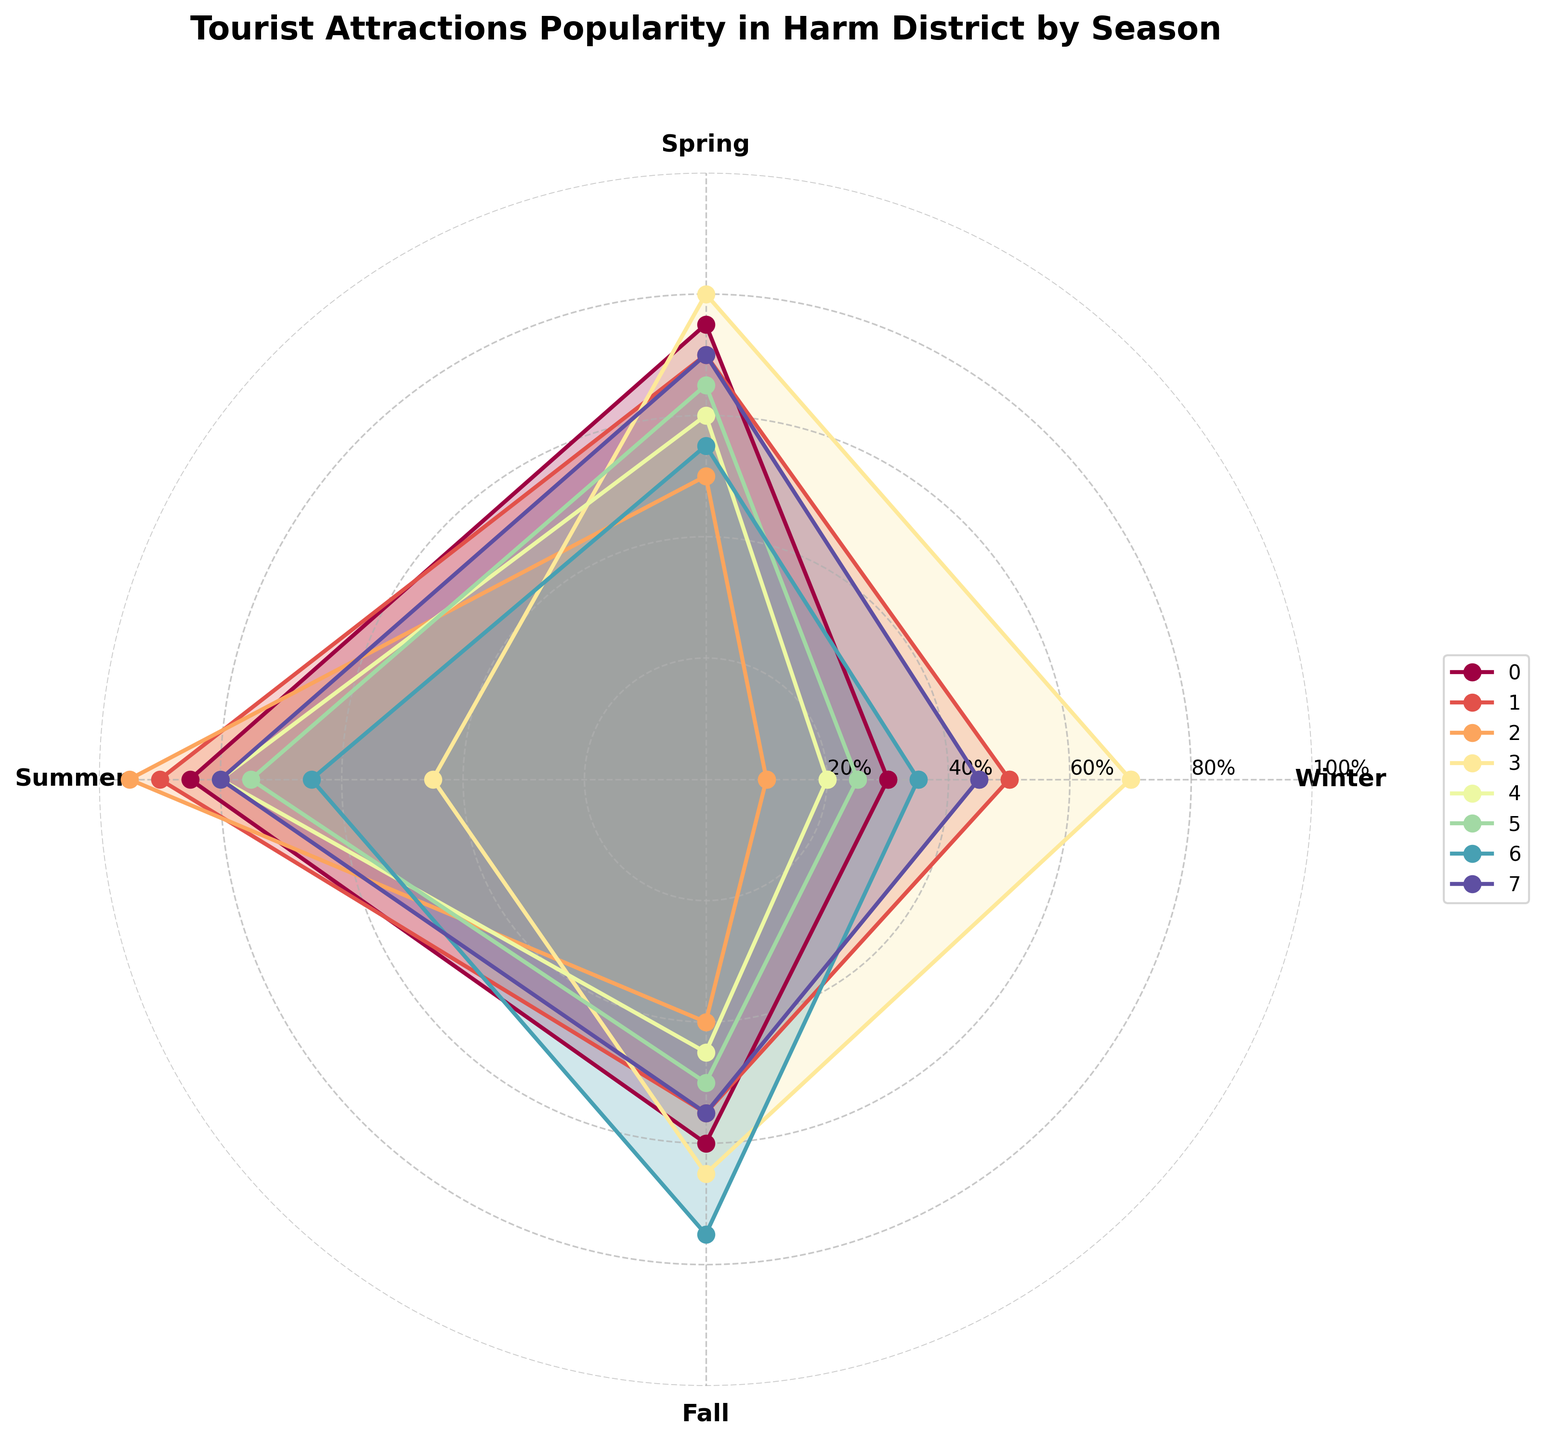Which tourist attraction has the highest popularity in Summer? In Summer, Sunny Beach has the highest value indicated on the chart compared to other attractions.
Answer: Sunny Beach Which season is Pinewood Forest least popular? Looking at the chart for Pinewood Forest, the value is lowest in Winter.
Answer: Winter Compare the popularity of Harm History Museum in Summer and Fall. Which season sees more visitors? The chart shows that Harm History Museum has 45% in Summer and 65% in Fall, so Fall has more visitors.
Answer: Fall What is the average popularity for Harm Falls across all seasons? Adding the values for Harm Falls across all seasons (30 + 75 + 85 + 60) and dividing by 4 gives the average: (250/4).
Answer: 62.5 Which tourist attraction is consistently popular across all seasons, without major fluctuations? Harm History Museum shows fairly consistent popularity values across seasons (70, 80, 45, 65), indicating less fluctuation.
Answer: Harm History Museum Which tourist attraction has the largest difference in popularity between Winter and Summer? For each attraction, calculate the difference between Winter and Summer values. Sunny Beach shows the largest difference of 85 (95-10).
Answer: Sunny Beach Compare the popularity of Lakeside Park in Fall with Skyline Tower. Which one is more popular? The chart shows that Lakeside Park is at 50% in Fall and Skyline Tower is at 45%, so Lakeside Park is more popular.
Answer: Lakeside Park How does the popularity of Harm Botanical Garden in Fall compare to its popularity in other seasons? Harm Botanical Garden has its peak in Fall with 75%, which is the highest compared to other seasons (35, 55, 65).
Answer: Higher in Fall Which season shows almost equal popularity for both Skyline Tower and Mountain Ridge Trail? Both Skyline Tower and Mountain Ridge Trail have 80% popularity in Summer, which is almost equal.
Answer: Summer 